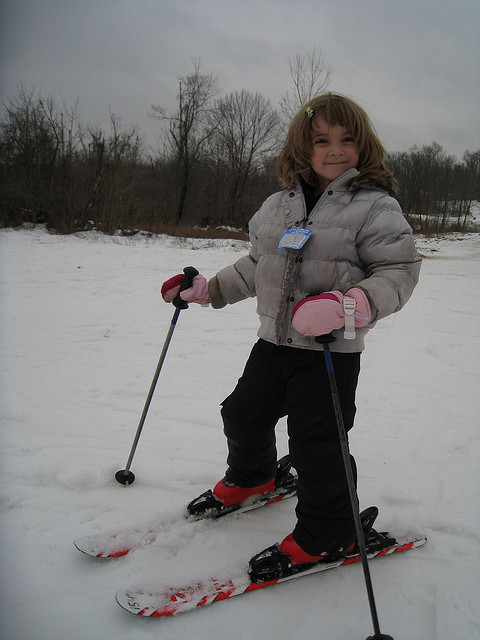What color are her mittens? The mittens the girl is wearing are bright pink, which stands out against the snowy backdrop and her light-colored jacket. 